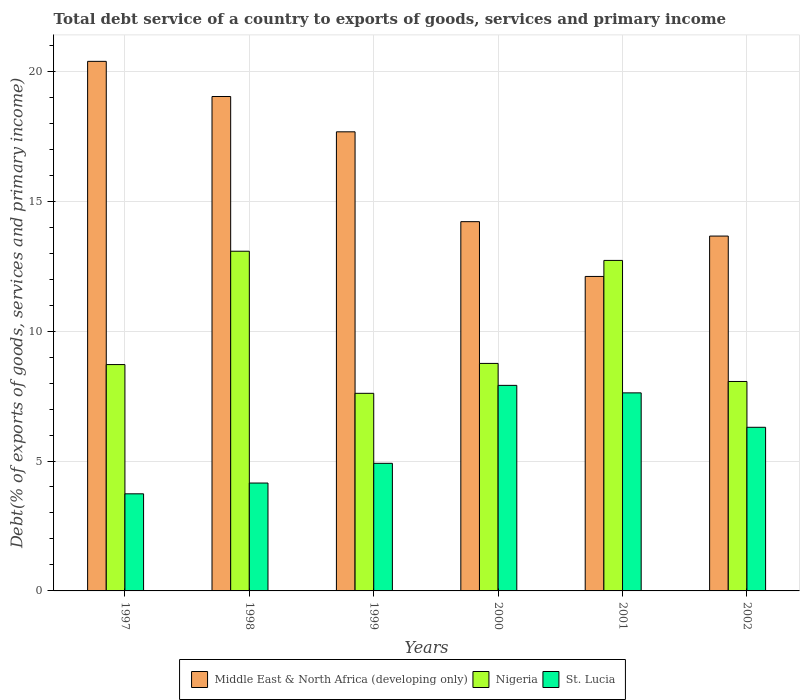How many different coloured bars are there?
Your answer should be very brief. 3. How many bars are there on the 6th tick from the left?
Offer a very short reply. 3. How many bars are there on the 4th tick from the right?
Offer a very short reply. 3. What is the label of the 6th group of bars from the left?
Offer a terse response. 2002. What is the total debt service in Nigeria in 2001?
Keep it short and to the point. 12.72. Across all years, what is the maximum total debt service in Middle East & North Africa (developing only)?
Your answer should be very brief. 20.38. Across all years, what is the minimum total debt service in St. Lucia?
Make the answer very short. 3.74. In which year was the total debt service in Middle East & North Africa (developing only) maximum?
Give a very brief answer. 1997. In which year was the total debt service in St. Lucia minimum?
Keep it short and to the point. 1997. What is the total total debt service in Nigeria in the graph?
Your answer should be compact. 58.93. What is the difference between the total debt service in Middle East & North Africa (developing only) in 1998 and that in 2001?
Provide a succinct answer. 6.93. What is the difference between the total debt service in Nigeria in 2000 and the total debt service in Middle East & North Africa (developing only) in 2001?
Make the answer very short. -3.35. What is the average total debt service in Middle East & North Africa (developing only) per year?
Provide a short and direct response. 16.18. In the year 2002, what is the difference between the total debt service in Nigeria and total debt service in St. Lucia?
Provide a succinct answer. 1.76. In how many years, is the total debt service in Nigeria greater than 5 %?
Keep it short and to the point. 6. What is the ratio of the total debt service in St. Lucia in 1998 to that in 1999?
Offer a terse response. 0.85. What is the difference between the highest and the second highest total debt service in Middle East & North Africa (developing only)?
Keep it short and to the point. 1.35. What is the difference between the highest and the lowest total debt service in St. Lucia?
Offer a very short reply. 4.17. What does the 2nd bar from the left in 1997 represents?
Give a very brief answer. Nigeria. What does the 1st bar from the right in 1999 represents?
Your answer should be compact. St. Lucia. Is it the case that in every year, the sum of the total debt service in St. Lucia and total debt service in Nigeria is greater than the total debt service in Middle East & North Africa (developing only)?
Your answer should be very brief. No. Are all the bars in the graph horizontal?
Give a very brief answer. No. How many years are there in the graph?
Give a very brief answer. 6. What is the difference between two consecutive major ticks on the Y-axis?
Provide a succinct answer. 5. Does the graph contain grids?
Offer a very short reply. Yes. Where does the legend appear in the graph?
Your answer should be compact. Bottom center. How many legend labels are there?
Ensure brevity in your answer.  3. How are the legend labels stacked?
Your answer should be very brief. Horizontal. What is the title of the graph?
Make the answer very short. Total debt service of a country to exports of goods, services and primary income. Does "Tanzania" appear as one of the legend labels in the graph?
Provide a short and direct response. No. What is the label or title of the X-axis?
Provide a succinct answer. Years. What is the label or title of the Y-axis?
Offer a very short reply. Debt(% of exports of goods, services and primary income). What is the Debt(% of exports of goods, services and primary income) of Middle East & North Africa (developing only) in 1997?
Make the answer very short. 20.38. What is the Debt(% of exports of goods, services and primary income) of Nigeria in 1997?
Provide a succinct answer. 8.71. What is the Debt(% of exports of goods, services and primary income) in St. Lucia in 1997?
Your answer should be compact. 3.74. What is the Debt(% of exports of goods, services and primary income) in Middle East & North Africa (developing only) in 1998?
Give a very brief answer. 19.03. What is the Debt(% of exports of goods, services and primary income) of Nigeria in 1998?
Make the answer very short. 13.07. What is the Debt(% of exports of goods, services and primary income) of St. Lucia in 1998?
Offer a very short reply. 4.15. What is the Debt(% of exports of goods, services and primary income) of Middle East & North Africa (developing only) in 1999?
Keep it short and to the point. 17.67. What is the Debt(% of exports of goods, services and primary income) of Nigeria in 1999?
Keep it short and to the point. 7.61. What is the Debt(% of exports of goods, services and primary income) of St. Lucia in 1999?
Offer a very short reply. 4.91. What is the Debt(% of exports of goods, services and primary income) in Middle East & North Africa (developing only) in 2000?
Provide a succinct answer. 14.21. What is the Debt(% of exports of goods, services and primary income) of Nigeria in 2000?
Offer a terse response. 8.76. What is the Debt(% of exports of goods, services and primary income) of St. Lucia in 2000?
Provide a short and direct response. 7.91. What is the Debt(% of exports of goods, services and primary income) of Middle East & North Africa (developing only) in 2001?
Offer a very short reply. 12.1. What is the Debt(% of exports of goods, services and primary income) of Nigeria in 2001?
Ensure brevity in your answer.  12.72. What is the Debt(% of exports of goods, services and primary income) in St. Lucia in 2001?
Make the answer very short. 7.62. What is the Debt(% of exports of goods, services and primary income) of Middle East & North Africa (developing only) in 2002?
Your answer should be compact. 13.66. What is the Debt(% of exports of goods, services and primary income) in Nigeria in 2002?
Make the answer very short. 8.06. What is the Debt(% of exports of goods, services and primary income) of St. Lucia in 2002?
Make the answer very short. 6.3. Across all years, what is the maximum Debt(% of exports of goods, services and primary income) in Middle East & North Africa (developing only)?
Provide a short and direct response. 20.38. Across all years, what is the maximum Debt(% of exports of goods, services and primary income) of Nigeria?
Offer a terse response. 13.07. Across all years, what is the maximum Debt(% of exports of goods, services and primary income) of St. Lucia?
Keep it short and to the point. 7.91. Across all years, what is the minimum Debt(% of exports of goods, services and primary income) in Middle East & North Africa (developing only)?
Provide a succinct answer. 12.1. Across all years, what is the minimum Debt(% of exports of goods, services and primary income) of Nigeria?
Offer a very short reply. 7.61. Across all years, what is the minimum Debt(% of exports of goods, services and primary income) of St. Lucia?
Your response must be concise. 3.74. What is the total Debt(% of exports of goods, services and primary income) in Middle East & North Africa (developing only) in the graph?
Offer a very short reply. 97.06. What is the total Debt(% of exports of goods, services and primary income) in Nigeria in the graph?
Give a very brief answer. 58.93. What is the total Debt(% of exports of goods, services and primary income) of St. Lucia in the graph?
Your answer should be very brief. 34.63. What is the difference between the Debt(% of exports of goods, services and primary income) in Middle East & North Africa (developing only) in 1997 and that in 1998?
Provide a succinct answer. 1.35. What is the difference between the Debt(% of exports of goods, services and primary income) in Nigeria in 1997 and that in 1998?
Your response must be concise. -4.36. What is the difference between the Debt(% of exports of goods, services and primary income) in St. Lucia in 1997 and that in 1998?
Your response must be concise. -0.41. What is the difference between the Debt(% of exports of goods, services and primary income) in Middle East & North Africa (developing only) in 1997 and that in 1999?
Your answer should be compact. 2.71. What is the difference between the Debt(% of exports of goods, services and primary income) in Nigeria in 1997 and that in 1999?
Provide a short and direct response. 1.11. What is the difference between the Debt(% of exports of goods, services and primary income) in St. Lucia in 1997 and that in 1999?
Provide a succinct answer. -1.17. What is the difference between the Debt(% of exports of goods, services and primary income) of Middle East & North Africa (developing only) in 1997 and that in 2000?
Make the answer very short. 6.17. What is the difference between the Debt(% of exports of goods, services and primary income) in Nigeria in 1997 and that in 2000?
Make the answer very short. -0.04. What is the difference between the Debt(% of exports of goods, services and primary income) in St. Lucia in 1997 and that in 2000?
Make the answer very short. -4.17. What is the difference between the Debt(% of exports of goods, services and primary income) of Middle East & North Africa (developing only) in 1997 and that in 2001?
Offer a very short reply. 8.28. What is the difference between the Debt(% of exports of goods, services and primary income) of Nigeria in 1997 and that in 2001?
Make the answer very short. -4.01. What is the difference between the Debt(% of exports of goods, services and primary income) in St. Lucia in 1997 and that in 2001?
Your response must be concise. -3.89. What is the difference between the Debt(% of exports of goods, services and primary income) in Middle East & North Africa (developing only) in 1997 and that in 2002?
Provide a short and direct response. 6.72. What is the difference between the Debt(% of exports of goods, services and primary income) of Nigeria in 1997 and that in 2002?
Your answer should be compact. 0.65. What is the difference between the Debt(% of exports of goods, services and primary income) of St. Lucia in 1997 and that in 2002?
Offer a very short reply. -2.56. What is the difference between the Debt(% of exports of goods, services and primary income) of Middle East & North Africa (developing only) in 1998 and that in 1999?
Offer a terse response. 1.36. What is the difference between the Debt(% of exports of goods, services and primary income) of Nigeria in 1998 and that in 1999?
Keep it short and to the point. 5.47. What is the difference between the Debt(% of exports of goods, services and primary income) in St. Lucia in 1998 and that in 1999?
Your answer should be very brief. -0.76. What is the difference between the Debt(% of exports of goods, services and primary income) in Middle East & North Africa (developing only) in 1998 and that in 2000?
Make the answer very short. 4.82. What is the difference between the Debt(% of exports of goods, services and primary income) of Nigeria in 1998 and that in 2000?
Your response must be concise. 4.32. What is the difference between the Debt(% of exports of goods, services and primary income) in St. Lucia in 1998 and that in 2000?
Offer a very short reply. -3.76. What is the difference between the Debt(% of exports of goods, services and primary income) in Middle East & North Africa (developing only) in 1998 and that in 2001?
Provide a short and direct response. 6.93. What is the difference between the Debt(% of exports of goods, services and primary income) in Nigeria in 1998 and that in 2001?
Your response must be concise. 0.35. What is the difference between the Debt(% of exports of goods, services and primary income) in St. Lucia in 1998 and that in 2001?
Give a very brief answer. -3.47. What is the difference between the Debt(% of exports of goods, services and primary income) of Middle East & North Africa (developing only) in 1998 and that in 2002?
Offer a terse response. 5.37. What is the difference between the Debt(% of exports of goods, services and primary income) of Nigeria in 1998 and that in 2002?
Ensure brevity in your answer.  5.01. What is the difference between the Debt(% of exports of goods, services and primary income) of St. Lucia in 1998 and that in 2002?
Offer a terse response. -2.15. What is the difference between the Debt(% of exports of goods, services and primary income) of Middle East & North Africa (developing only) in 1999 and that in 2000?
Your response must be concise. 3.46. What is the difference between the Debt(% of exports of goods, services and primary income) of Nigeria in 1999 and that in 2000?
Offer a very short reply. -1.15. What is the difference between the Debt(% of exports of goods, services and primary income) of St. Lucia in 1999 and that in 2000?
Give a very brief answer. -3. What is the difference between the Debt(% of exports of goods, services and primary income) in Middle East & North Africa (developing only) in 1999 and that in 2001?
Give a very brief answer. 5.57. What is the difference between the Debt(% of exports of goods, services and primary income) of Nigeria in 1999 and that in 2001?
Keep it short and to the point. -5.12. What is the difference between the Debt(% of exports of goods, services and primary income) in St. Lucia in 1999 and that in 2001?
Your answer should be very brief. -2.71. What is the difference between the Debt(% of exports of goods, services and primary income) of Middle East & North Africa (developing only) in 1999 and that in 2002?
Your response must be concise. 4.01. What is the difference between the Debt(% of exports of goods, services and primary income) in Nigeria in 1999 and that in 2002?
Your answer should be compact. -0.46. What is the difference between the Debt(% of exports of goods, services and primary income) in St. Lucia in 1999 and that in 2002?
Offer a terse response. -1.39. What is the difference between the Debt(% of exports of goods, services and primary income) of Middle East & North Africa (developing only) in 2000 and that in 2001?
Ensure brevity in your answer.  2.11. What is the difference between the Debt(% of exports of goods, services and primary income) in Nigeria in 2000 and that in 2001?
Your answer should be compact. -3.96. What is the difference between the Debt(% of exports of goods, services and primary income) in St. Lucia in 2000 and that in 2001?
Your answer should be very brief. 0.29. What is the difference between the Debt(% of exports of goods, services and primary income) of Middle East & North Africa (developing only) in 2000 and that in 2002?
Ensure brevity in your answer.  0.55. What is the difference between the Debt(% of exports of goods, services and primary income) of Nigeria in 2000 and that in 2002?
Keep it short and to the point. 0.7. What is the difference between the Debt(% of exports of goods, services and primary income) of St. Lucia in 2000 and that in 2002?
Provide a short and direct response. 1.61. What is the difference between the Debt(% of exports of goods, services and primary income) of Middle East & North Africa (developing only) in 2001 and that in 2002?
Your answer should be compact. -1.55. What is the difference between the Debt(% of exports of goods, services and primary income) of Nigeria in 2001 and that in 2002?
Provide a short and direct response. 4.66. What is the difference between the Debt(% of exports of goods, services and primary income) of St. Lucia in 2001 and that in 2002?
Offer a very short reply. 1.33. What is the difference between the Debt(% of exports of goods, services and primary income) of Middle East & North Africa (developing only) in 1997 and the Debt(% of exports of goods, services and primary income) of Nigeria in 1998?
Provide a short and direct response. 7.31. What is the difference between the Debt(% of exports of goods, services and primary income) in Middle East & North Africa (developing only) in 1997 and the Debt(% of exports of goods, services and primary income) in St. Lucia in 1998?
Give a very brief answer. 16.23. What is the difference between the Debt(% of exports of goods, services and primary income) in Nigeria in 1997 and the Debt(% of exports of goods, services and primary income) in St. Lucia in 1998?
Provide a short and direct response. 4.56. What is the difference between the Debt(% of exports of goods, services and primary income) of Middle East & North Africa (developing only) in 1997 and the Debt(% of exports of goods, services and primary income) of Nigeria in 1999?
Your answer should be very brief. 12.78. What is the difference between the Debt(% of exports of goods, services and primary income) of Middle East & North Africa (developing only) in 1997 and the Debt(% of exports of goods, services and primary income) of St. Lucia in 1999?
Provide a succinct answer. 15.47. What is the difference between the Debt(% of exports of goods, services and primary income) of Nigeria in 1997 and the Debt(% of exports of goods, services and primary income) of St. Lucia in 1999?
Make the answer very short. 3.8. What is the difference between the Debt(% of exports of goods, services and primary income) of Middle East & North Africa (developing only) in 1997 and the Debt(% of exports of goods, services and primary income) of Nigeria in 2000?
Give a very brief answer. 11.63. What is the difference between the Debt(% of exports of goods, services and primary income) in Middle East & North Africa (developing only) in 1997 and the Debt(% of exports of goods, services and primary income) in St. Lucia in 2000?
Keep it short and to the point. 12.47. What is the difference between the Debt(% of exports of goods, services and primary income) in Nigeria in 1997 and the Debt(% of exports of goods, services and primary income) in St. Lucia in 2000?
Offer a very short reply. 0.8. What is the difference between the Debt(% of exports of goods, services and primary income) of Middle East & North Africa (developing only) in 1997 and the Debt(% of exports of goods, services and primary income) of Nigeria in 2001?
Offer a very short reply. 7.66. What is the difference between the Debt(% of exports of goods, services and primary income) of Middle East & North Africa (developing only) in 1997 and the Debt(% of exports of goods, services and primary income) of St. Lucia in 2001?
Provide a short and direct response. 12.76. What is the difference between the Debt(% of exports of goods, services and primary income) in Nigeria in 1997 and the Debt(% of exports of goods, services and primary income) in St. Lucia in 2001?
Ensure brevity in your answer.  1.09. What is the difference between the Debt(% of exports of goods, services and primary income) of Middle East & North Africa (developing only) in 1997 and the Debt(% of exports of goods, services and primary income) of Nigeria in 2002?
Offer a very short reply. 12.32. What is the difference between the Debt(% of exports of goods, services and primary income) of Middle East & North Africa (developing only) in 1997 and the Debt(% of exports of goods, services and primary income) of St. Lucia in 2002?
Your answer should be very brief. 14.08. What is the difference between the Debt(% of exports of goods, services and primary income) of Nigeria in 1997 and the Debt(% of exports of goods, services and primary income) of St. Lucia in 2002?
Keep it short and to the point. 2.41. What is the difference between the Debt(% of exports of goods, services and primary income) of Middle East & North Africa (developing only) in 1998 and the Debt(% of exports of goods, services and primary income) of Nigeria in 1999?
Your response must be concise. 11.42. What is the difference between the Debt(% of exports of goods, services and primary income) of Middle East & North Africa (developing only) in 1998 and the Debt(% of exports of goods, services and primary income) of St. Lucia in 1999?
Your answer should be very brief. 14.12. What is the difference between the Debt(% of exports of goods, services and primary income) of Nigeria in 1998 and the Debt(% of exports of goods, services and primary income) of St. Lucia in 1999?
Provide a succinct answer. 8.16. What is the difference between the Debt(% of exports of goods, services and primary income) of Middle East & North Africa (developing only) in 1998 and the Debt(% of exports of goods, services and primary income) of Nigeria in 2000?
Keep it short and to the point. 10.27. What is the difference between the Debt(% of exports of goods, services and primary income) in Middle East & North Africa (developing only) in 1998 and the Debt(% of exports of goods, services and primary income) in St. Lucia in 2000?
Your response must be concise. 11.12. What is the difference between the Debt(% of exports of goods, services and primary income) of Nigeria in 1998 and the Debt(% of exports of goods, services and primary income) of St. Lucia in 2000?
Provide a succinct answer. 5.16. What is the difference between the Debt(% of exports of goods, services and primary income) in Middle East & North Africa (developing only) in 1998 and the Debt(% of exports of goods, services and primary income) in Nigeria in 2001?
Provide a short and direct response. 6.31. What is the difference between the Debt(% of exports of goods, services and primary income) of Middle East & North Africa (developing only) in 1998 and the Debt(% of exports of goods, services and primary income) of St. Lucia in 2001?
Your answer should be compact. 11.41. What is the difference between the Debt(% of exports of goods, services and primary income) of Nigeria in 1998 and the Debt(% of exports of goods, services and primary income) of St. Lucia in 2001?
Provide a short and direct response. 5.45. What is the difference between the Debt(% of exports of goods, services and primary income) in Middle East & North Africa (developing only) in 1998 and the Debt(% of exports of goods, services and primary income) in Nigeria in 2002?
Offer a terse response. 10.97. What is the difference between the Debt(% of exports of goods, services and primary income) in Middle East & North Africa (developing only) in 1998 and the Debt(% of exports of goods, services and primary income) in St. Lucia in 2002?
Your answer should be compact. 12.73. What is the difference between the Debt(% of exports of goods, services and primary income) of Nigeria in 1998 and the Debt(% of exports of goods, services and primary income) of St. Lucia in 2002?
Give a very brief answer. 6.78. What is the difference between the Debt(% of exports of goods, services and primary income) of Middle East & North Africa (developing only) in 1999 and the Debt(% of exports of goods, services and primary income) of Nigeria in 2000?
Offer a terse response. 8.91. What is the difference between the Debt(% of exports of goods, services and primary income) of Middle East & North Africa (developing only) in 1999 and the Debt(% of exports of goods, services and primary income) of St. Lucia in 2000?
Your answer should be very brief. 9.76. What is the difference between the Debt(% of exports of goods, services and primary income) of Nigeria in 1999 and the Debt(% of exports of goods, services and primary income) of St. Lucia in 2000?
Your answer should be compact. -0.31. What is the difference between the Debt(% of exports of goods, services and primary income) of Middle East & North Africa (developing only) in 1999 and the Debt(% of exports of goods, services and primary income) of Nigeria in 2001?
Give a very brief answer. 4.95. What is the difference between the Debt(% of exports of goods, services and primary income) of Middle East & North Africa (developing only) in 1999 and the Debt(% of exports of goods, services and primary income) of St. Lucia in 2001?
Your answer should be compact. 10.05. What is the difference between the Debt(% of exports of goods, services and primary income) of Nigeria in 1999 and the Debt(% of exports of goods, services and primary income) of St. Lucia in 2001?
Offer a terse response. -0.02. What is the difference between the Debt(% of exports of goods, services and primary income) of Middle East & North Africa (developing only) in 1999 and the Debt(% of exports of goods, services and primary income) of Nigeria in 2002?
Your answer should be compact. 9.61. What is the difference between the Debt(% of exports of goods, services and primary income) of Middle East & North Africa (developing only) in 1999 and the Debt(% of exports of goods, services and primary income) of St. Lucia in 2002?
Keep it short and to the point. 11.37. What is the difference between the Debt(% of exports of goods, services and primary income) of Nigeria in 1999 and the Debt(% of exports of goods, services and primary income) of St. Lucia in 2002?
Give a very brief answer. 1.31. What is the difference between the Debt(% of exports of goods, services and primary income) in Middle East & North Africa (developing only) in 2000 and the Debt(% of exports of goods, services and primary income) in Nigeria in 2001?
Offer a terse response. 1.49. What is the difference between the Debt(% of exports of goods, services and primary income) in Middle East & North Africa (developing only) in 2000 and the Debt(% of exports of goods, services and primary income) in St. Lucia in 2001?
Keep it short and to the point. 6.59. What is the difference between the Debt(% of exports of goods, services and primary income) of Nigeria in 2000 and the Debt(% of exports of goods, services and primary income) of St. Lucia in 2001?
Ensure brevity in your answer.  1.13. What is the difference between the Debt(% of exports of goods, services and primary income) in Middle East & North Africa (developing only) in 2000 and the Debt(% of exports of goods, services and primary income) in Nigeria in 2002?
Offer a very short reply. 6.15. What is the difference between the Debt(% of exports of goods, services and primary income) in Middle East & North Africa (developing only) in 2000 and the Debt(% of exports of goods, services and primary income) in St. Lucia in 2002?
Give a very brief answer. 7.91. What is the difference between the Debt(% of exports of goods, services and primary income) in Nigeria in 2000 and the Debt(% of exports of goods, services and primary income) in St. Lucia in 2002?
Your response must be concise. 2.46. What is the difference between the Debt(% of exports of goods, services and primary income) in Middle East & North Africa (developing only) in 2001 and the Debt(% of exports of goods, services and primary income) in Nigeria in 2002?
Give a very brief answer. 4.04. What is the difference between the Debt(% of exports of goods, services and primary income) in Middle East & North Africa (developing only) in 2001 and the Debt(% of exports of goods, services and primary income) in St. Lucia in 2002?
Offer a very short reply. 5.81. What is the difference between the Debt(% of exports of goods, services and primary income) in Nigeria in 2001 and the Debt(% of exports of goods, services and primary income) in St. Lucia in 2002?
Offer a terse response. 6.42. What is the average Debt(% of exports of goods, services and primary income) of Middle East & North Africa (developing only) per year?
Keep it short and to the point. 16.18. What is the average Debt(% of exports of goods, services and primary income) of Nigeria per year?
Offer a terse response. 9.82. What is the average Debt(% of exports of goods, services and primary income) of St. Lucia per year?
Provide a short and direct response. 5.77. In the year 1997, what is the difference between the Debt(% of exports of goods, services and primary income) in Middle East & North Africa (developing only) and Debt(% of exports of goods, services and primary income) in Nigeria?
Your answer should be compact. 11.67. In the year 1997, what is the difference between the Debt(% of exports of goods, services and primary income) of Middle East & North Africa (developing only) and Debt(% of exports of goods, services and primary income) of St. Lucia?
Offer a terse response. 16.64. In the year 1997, what is the difference between the Debt(% of exports of goods, services and primary income) of Nigeria and Debt(% of exports of goods, services and primary income) of St. Lucia?
Keep it short and to the point. 4.97. In the year 1998, what is the difference between the Debt(% of exports of goods, services and primary income) in Middle East & North Africa (developing only) and Debt(% of exports of goods, services and primary income) in Nigeria?
Your answer should be compact. 5.95. In the year 1998, what is the difference between the Debt(% of exports of goods, services and primary income) in Middle East & North Africa (developing only) and Debt(% of exports of goods, services and primary income) in St. Lucia?
Your response must be concise. 14.88. In the year 1998, what is the difference between the Debt(% of exports of goods, services and primary income) of Nigeria and Debt(% of exports of goods, services and primary income) of St. Lucia?
Give a very brief answer. 8.92. In the year 1999, what is the difference between the Debt(% of exports of goods, services and primary income) in Middle East & North Africa (developing only) and Debt(% of exports of goods, services and primary income) in Nigeria?
Offer a very short reply. 10.06. In the year 1999, what is the difference between the Debt(% of exports of goods, services and primary income) of Middle East & North Africa (developing only) and Debt(% of exports of goods, services and primary income) of St. Lucia?
Your answer should be compact. 12.76. In the year 1999, what is the difference between the Debt(% of exports of goods, services and primary income) of Nigeria and Debt(% of exports of goods, services and primary income) of St. Lucia?
Your answer should be very brief. 2.69. In the year 2000, what is the difference between the Debt(% of exports of goods, services and primary income) in Middle East & North Africa (developing only) and Debt(% of exports of goods, services and primary income) in Nigeria?
Ensure brevity in your answer.  5.46. In the year 2000, what is the difference between the Debt(% of exports of goods, services and primary income) of Middle East & North Africa (developing only) and Debt(% of exports of goods, services and primary income) of St. Lucia?
Provide a succinct answer. 6.3. In the year 2000, what is the difference between the Debt(% of exports of goods, services and primary income) of Nigeria and Debt(% of exports of goods, services and primary income) of St. Lucia?
Keep it short and to the point. 0.84. In the year 2001, what is the difference between the Debt(% of exports of goods, services and primary income) in Middle East & North Africa (developing only) and Debt(% of exports of goods, services and primary income) in Nigeria?
Give a very brief answer. -0.62. In the year 2001, what is the difference between the Debt(% of exports of goods, services and primary income) in Middle East & North Africa (developing only) and Debt(% of exports of goods, services and primary income) in St. Lucia?
Offer a terse response. 4.48. In the year 2001, what is the difference between the Debt(% of exports of goods, services and primary income) in Nigeria and Debt(% of exports of goods, services and primary income) in St. Lucia?
Offer a terse response. 5.1. In the year 2002, what is the difference between the Debt(% of exports of goods, services and primary income) in Middle East & North Africa (developing only) and Debt(% of exports of goods, services and primary income) in Nigeria?
Keep it short and to the point. 5.6. In the year 2002, what is the difference between the Debt(% of exports of goods, services and primary income) in Middle East & North Africa (developing only) and Debt(% of exports of goods, services and primary income) in St. Lucia?
Make the answer very short. 7.36. In the year 2002, what is the difference between the Debt(% of exports of goods, services and primary income) in Nigeria and Debt(% of exports of goods, services and primary income) in St. Lucia?
Give a very brief answer. 1.76. What is the ratio of the Debt(% of exports of goods, services and primary income) of Middle East & North Africa (developing only) in 1997 to that in 1998?
Provide a short and direct response. 1.07. What is the ratio of the Debt(% of exports of goods, services and primary income) of Nigeria in 1997 to that in 1998?
Your answer should be very brief. 0.67. What is the ratio of the Debt(% of exports of goods, services and primary income) of St. Lucia in 1997 to that in 1998?
Provide a short and direct response. 0.9. What is the ratio of the Debt(% of exports of goods, services and primary income) of Middle East & North Africa (developing only) in 1997 to that in 1999?
Your answer should be very brief. 1.15. What is the ratio of the Debt(% of exports of goods, services and primary income) in Nigeria in 1997 to that in 1999?
Provide a succinct answer. 1.15. What is the ratio of the Debt(% of exports of goods, services and primary income) of St. Lucia in 1997 to that in 1999?
Keep it short and to the point. 0.76. What is the ratio of the Debt(% of exports of goods, services and primary income) of Middle East & North Africa (developing only) in 1997 to that in 2000?
Offer a terse response. 1.43. What is the ratio of the Debt(% of exports of goods, services and primary income) of Nigeria in 1997 to that in 2000?
Make the answer very short. 0.99. What is the ratio of the Debt(% of exports of goods, services and primary income) of St. Lucia in 1997 to that in 2000?
Offer a terse response. 0.47. What is the ratio of the Debt(% of exports of goods, services and primary income) in Middle East & North Africa (developing only) in 1997 to that in 2001?
Provide a short and direct response. 1.68. What is the ratio of the Debt(% of exports of goods, services and primary income) of Nigeria in 1997 to that in 2001?
Make the answer very short. 0.68. What is the ratio of the Debt(% of exports of goods, services and primary income) in St. Lucia in 1997 to that in 2001?
Your answer should be compact. 0.49. What is the ratio of the Debt(% of exports of goods, services and primary income) of Middle East & North Africa (developing only) in 1997 to that in 2002?
Provide a succinct answer. 1.49. What is the ratio of the Debt(% of exports of goods, services and primary income) of Nigeria in 1997 to that in 2002?
Keep it short and to the point. 1.08. What is the ratio of the Debt(% of exports of goods, services and primary income) in St. Lucia in 1997 to that in 2002?
Ensure brevity in your answer.  0.59. What is the ratio of the Debt(% of exports of goods, services and primary income) of Nigeria in 1998 to that in 1999?
Ensure brevity in your answer.  1.72. What is the ratio of the Debt(% of exports of goods, services and primary income) of St. Lucia in 1998 to that in 1999?
Provide a short and direct response. 0.85. What is the ratio of the Debt(% of exports of goods, services and primary income) of Middle East & North Africa (developing only) in 1998 to that in 2000?
Keep it short and to the point. 1.34. What is the ratio of the Debt(% of exports of goods, services and primary income) in Nigeria in 1998 to that in 2000?
Give a very brief answer. 1.49. What is the ratio of the Debt(% of exports of goods, services and primary income) in St. Lucia in 1998 to that in 2000?
Provide a short and direct response. 0.52. What is the ratio of the Debt(% of exports of goods, services and primary income) of Middle East & North Africa (developing only) in 1998 to that in 2001?
Your answer should be very brief. 1.57. What is the ratio of the Debt(% of exports of goods, services and primary income) in Nigeria in 1998 to that in 2001?
Make the answer very short. 1.03. What is the ratio of the Debt(% of exports of goods, services and primary income) of St. Lucia in 1998 to that in 2001?
Make the answer very short. 0.54. What is the ratio of the Debt(% of exports of goods, services and primary income) of Middle East & North Africa (developing only) in 1998 to that in 2002?
Your answer should be compact. 1.39. What is the ratio of the Debt(% of exports of goods, services and primary income) in Nigeria in 1998 to that in 2002?
Make the answer very short. 1.62. What is the ratio of the Debt(% of exports of goods, services and primary income) in St. Lucia in 1998 to that in 2002?
Offer a terse response. 0.66. What is the ratio of the Debt(% of exports of goods, services and primary income) in Middle East & North Africa (developing only) in 1999 to that in 2000?
Keep it short and to the point. 1.24. What is the ratio of the Debt(% of exports of goods, services and primary income) of Nigeria in 1999 to that in 2000?
Provide a succinct answer. 0.87. What is the ratio of the Debt(% of exports of goods, services and primary income) of St. Lucia in 1999 to that in 2000?
Provide a short and direct response. 0.62. What is the ratio of the Debt(% of exports of goods, services and primary income) of Middle East & North Africa (developing only) in 1999 to that in 2001?
Keep it short and to the point. 1.46. What is the ratio of the Debt(% of exports of goods, services and primary income) in Nigeria in 1999 to that in 2001?
Your response must be concise. 0.6. What is the ratio of the Debt(% of exports of goods, services and primary income) in St. Lucia in 1999 to that in 2001?
Your answer should be very brief. 0.64. What is the ratio of the Debt(% of exports of goods, services and primary income) of Middle East & North Africa (developing only) in 1999 to that in 2002?
Your answer should be compact. 1.29. What is the ratio of the Debt(% of exports of goods, services and primary income) in Nigeria in 1999 to that in 2002?
Make the answer very short. 0.94. What is the ratio of the Debt(% of exports of goods, services and primary income) in St. Lucia in 1999 to that in 2002?
Your answer should be compact. 0.78. What is the ratio of the Debt(% of exports of goods, services and primary income) of Middle East & North Africa (developing only) in 2000 to that in 2001?
Keep it short and to the point. 1.17. What is the ratio of the Debt(% of exports of goods, services and primary income) of Nigeria in 2000 to that in 2001?
Keep it short and to the point. 0.69. What is the ratio of the Debt(% of exports of goods, services and primary income) of St. Lucia in 2000 to that in 2001?
Give a very brief answer. 1.04. What is the ratio of the Debt(% of exports of goods, services and primary income) of Middle East & North Africa (developing only) in 2000 to that in 2002?
Your answer should be very brief. 1.04. What is the ratio of the Debt(% of exports of goods, services and primary income) in Nigeria in 2000 to that in 2002?
Give a very brief answer. 1.09. What is the ratio of the Debt(% of exports of goods, services and primary income) in St. Lucia in 2000 to that in 2002?
Make the answer very short. 1.26. What is the ratio of the Debt(% of exports of goods, services and primary income) of Middle East & North Africa (developing only) in 2001 to that in 2002?
Your response must be concise. 0.89. What is the ratio of the Debt(% of exports of goods, services and primary income) of Nigeria in 2001 to that in 2002?
Your answer should be very brief. 1.58. What is the ratio of the Debt(% of exports of goods, services and primary income) in St. Lucia in 2001 to that in 2002?
Provide a short and direct response. 1.21. What is the difference between the highest and the second highest Debt(% of exports of goods, services and primary income) of Middle East & North Africa (developing only)?
Make the answer very short. 1.35. What is the difference between the highest and the second highest Debt(% of exports of goods, services and primary income) of Nigeria?
Ensure brevity in your answer.  0.35. What is the difference between the highest and the second highest Debt(% of exports of goods, services and primary income) in St. Lucia?
Ensure brevity in your answer.  0.29. What is the difference between the highest and the lowest Debt(% of exports of goods, services and primary income) in Middle East & North Africa (developing only)?
Provide a short and direct response. 8.28. What is the difference between the highest and the lowest Debt(% of exports of goods, services and primary income) in Nigeria?
Your answer should be compact. 5.47. What is the difference between the highest and the lowest Debt(% of exports of goods, services and primary income) of St. Lucia?
Provide a short and direct response. 4.17. 